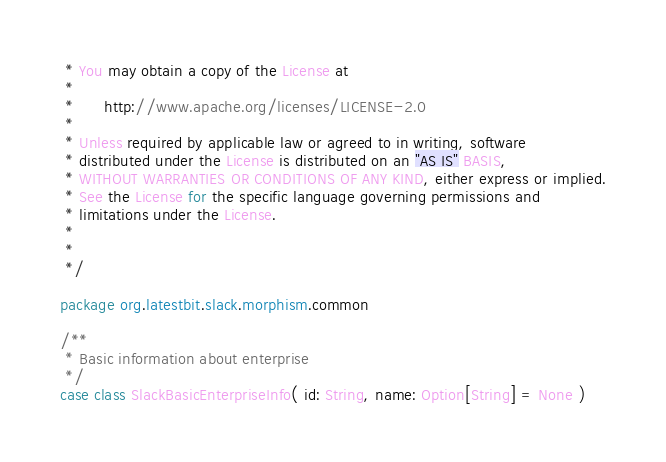Convert code to text. <code><loc_0><loc_0><loc_500><loc_500><_Scala_> * You may obtain a copy of the License at
 *
 *      http://www.apache.org/licenses/LICENSE-2.0
 *
 * Unless required by applicable law or agreed to in writing, software
 * distributed under the License is distributed on an "AS IS" BASIS,
 * WITHOUT WARRANTIES OR CONDITIONS OF ANY KIND, either express or implied.
 * See the License for the specific language governing permissions and
 * limitations under the License.
 *
 *
 */

package org.latestbit.slack.morphism.common

/**
 * Basic information about enterprise
 */
case class SlackBasicEnterpriseInfo( id: String, name: Option[String] = None )
</code> 